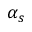<formula> <loc_0><loc_0><loc_500><loc_500>\alpha _ { s }</formula> 